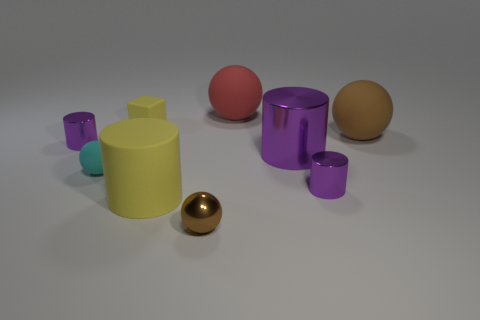Do the big yellow cylinder and the red ball have the same material?
Give a very brief answer. Yes. How many red metallic blocks have the same size as the red thing?
Give a very brief answer. 0. Are there an equal number of brown matte things on the left side of the brown rubber object and tiny purple shiny balls?
Give a very brief answer. Yes. What number of small objects are both on the left side of the red rubber object and on the right side of the cube?
Give a very brief answer. 1. Do the small purple shiny object left of the block and the red thing have the same shape?
Provide a succinct answer. No. There is a cyan ball that is the same size as the brown metal ball; what material is it?
Your answer should be very brief. Rubber. Are there the same number of red things to the right of the large red matte object and yellow blocks that are right of the brown rubber sphere?
Give a very brief answer. Yes. What number of tiny metal things are in front of the yellow object in front of the metal cylinder to the left of the brown metallic object?
Provide a succinct answer. 1. Does the cube have the same color as the large cylinder left of the large red rubber sphere?
Keep it short and to the point. Yes. There is a brown sphere that is the same material as the big yellow cylinder; what size is it?
Provide a succinct answer. Large. 